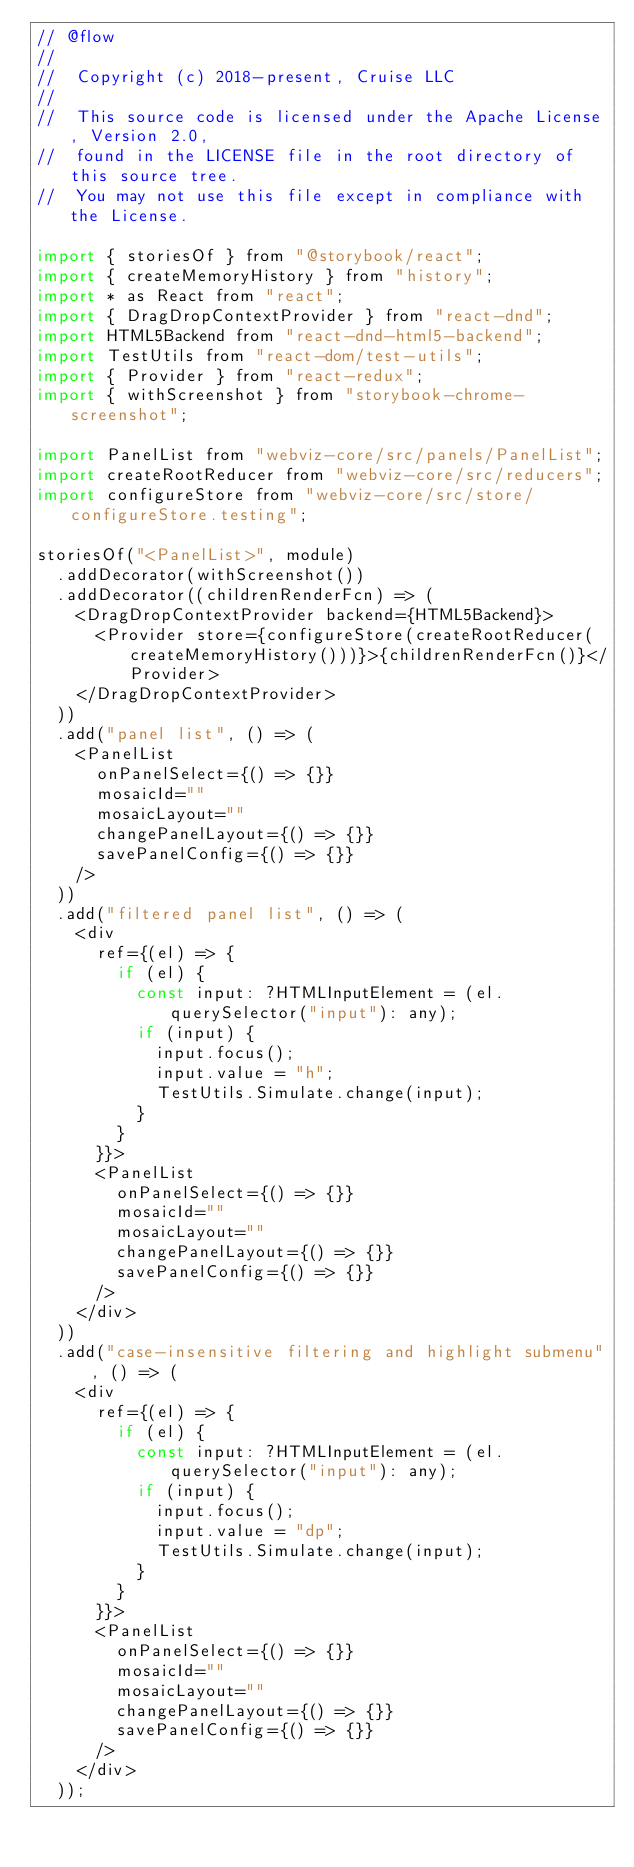Convert code to text. <code><loc_0><loc_0><loc_500><loc_500><_JavaScript_>// @flow
//
//  Copyright (c) 2018-present, Cruise LLC
//
//  This source code is licensed under the Apache License, Version 2.0,
//  found in the LICENSE file in the root directory of this source tree.
//  You may not use this file except in compliance with the License.

import { storiesOf } from "@storybook/react";
import { createMemoryHistory } from "history";
import * as React from "react";
import { DragDropContextProvider } from "react-dnd";
import HTML5Backend from "react-dnd-html5-backend";
import TestUtils from "react-dom/test-utils";
import { Provider } from "react-redux";
import { withScreenshot } from "storybook-chrome-screenshot";

import PanelList from "webviz-core/src/panels/PanelList";
import createRootReducer from "webviz-core/src/reducers";
import configureStore from "webviz-core/src/store/configureStore.testing";

storiesOf("<PanelList>", module)
  .addDecorator(withScreenshot())
  .addDecorator((childrenRenderFcn) => (
    <DragDropContextProvider backend={HTML5Backend}>
      <Provider store={configureStore(createRootReducer(createMemoryHistory()))}>{childrenRenderFcn()}</Provider>
    </DragDropContextProvider>
  ))
  .add("panel list", () => (
    <PanelList
      onPanelSelect={() => {}}
      mosaicId=""
      mosaicLayout=""
      changePanelLayout={() => {}}
      savePanelConfig={() => {}}
    />
  ))
  .add("filtered panel list", () => (
    <div
      ref={(el) => {
        if (el) {
          const input: ?HTMLInputElement = (el.querySelector("input"): any);
          if (input) {
            input.focus();
            input.value = "h";
            TestUtils.Simulate.change(input);
          }
        }
      }}>
      <PanelList
        onPanelSelect={() => {}}
        mosaicId=""
        mosaicLayout=""
        changePanelLayout={() => {}}
        savePanelConfig={() => {}}
      />
    </div>
  ))
  .add("case-insensitive filtering and highlight submenu", () => (
    <div
      ref={(el) => {
        if (el) {
          const input: ?HTMLInputElement = (el.querySelector("input"): any);
          if (input) {
            input.focus();
            input.value = "dp";
            TestUtils.Simulate.change(input);
          }
        }
      }}>
      <PanelList
        onPanelSelect={() => {}}
        mosaicId=""
        mosaicLayout=""
        changePanelLayout={() => {}}
        savePanelConfig={() => {}}
      />
    </div>
  ));
</code> 